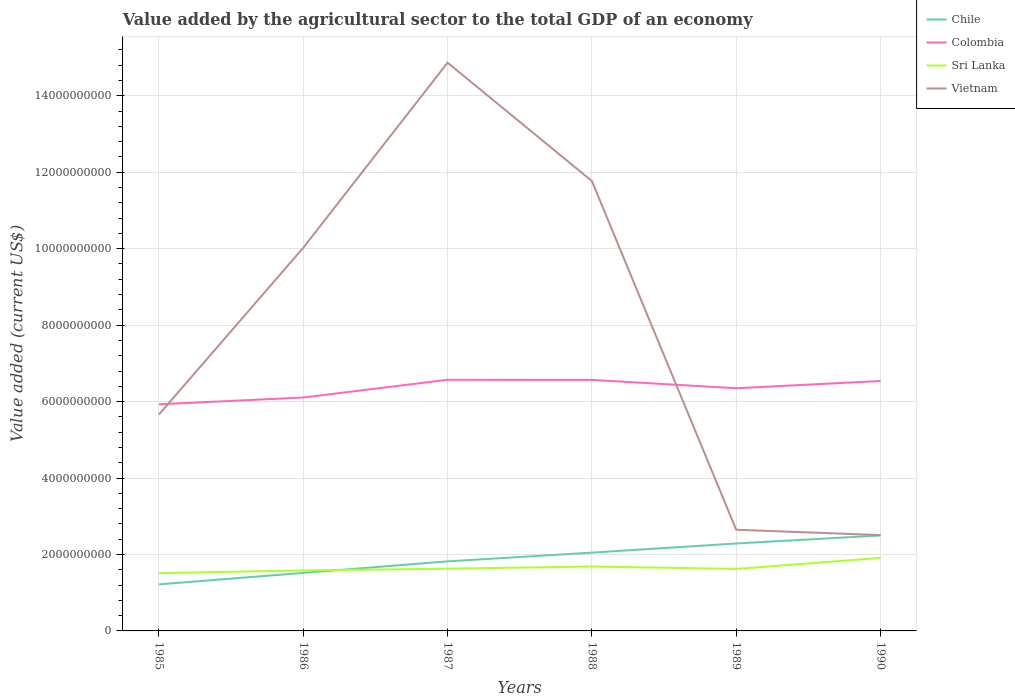How many different coloured lines are there?
Make the answer very short. 4. Does the line corresponding to Chile intersect with the line corresponding to Colombia?
Your response must be concise. No. Is the number of lines equal to the number of legend labels?
Ensure brevity in your answer.  Yes. Across all years, what is the maximum value added by the agricultural sector to the total GDP in Sri Lanka?
Provide a short and direct response. 1.51e+09. In which year was the value added by the agricultural sector to the total GDP in Vietnam maximum?
Provide a succinct answer. 1990. What is the total value added by the agricultural sector to the total GDP in Vietnam in the graph?
Keep it short and to the point. 3.16e+09. What is the difference between the highest and the second highest value added by the agricultural sector to the total GDP in Vietnam?
Your answer should be compact. 1.24e+1. What is the difference between the highest and the lowest value added by the agricultural sector to the total GDP in Sri Lanka?
Give a very brief answer. 2. Is the value added by the agricultural sector to the total GDP in Vietnam strictly greater than the value added by the agricultural sector to the total GDP in Colombia over the years?
Provide a short and direct response. No. How many lines are there?
Provide a short and direct response. 4. Where does the legend appear in the graph?
Ensure brevity in your answer.  Top right. What is the title of the graph?
Make the answer very short. Value added by the agricultural sector to the total GDP of an economy. Does "Guatemala" appear as one of the legend labels in the graph?
Make the answer very short. No. What is the label or title of the Y-axis?
Keep it short and to the point. Value added (current US$). What is the Value added (current US$) of Chile in 1985?
Make the answer very short. 1.22e+09. What is the Value added (current US$) in Colombia in 1985?
Your answer should be compact. 5.93e+09. What is the Value added (current US$) of Sri Lanka in 1985?
Your response must be concise. 1.51e+09. What is the Value added (current US$) in Vietnam in 1985?
Your answer should be compact. 5.66e+09. What is the Value added (current US$) in Chile in 1986?
Keep it short and to the point. 1.52e+09. What is the Value added (current US$) in Colombia in 1986?
Your answer should be compact. 6.11e+09. What is the Value added (current US$) of Sri Lanka in 1986?
Make the answer very short. 1.58e+09. What is the Value added (current US$) in Vietnam in 1986?
Keep it short and to the point. 1.00e+1. What is the Value added (current US$) in Chile in 1987?
Make the answer very short. 1.82e+09. What is the Value added (current US$) in Colombia in 1987?
Give a very brief answer. 6.57e+09. What is the Value added (current US$) in Sri Lanka in 1987?
Offer a very short reply. 1.63e+09. What is the Value added (current US$) in Vietnam in 1987?
Give a very brief answer. 1.49e+1. What is the Value added (current US$) in Chile in 1988?
Ensure brevity in your answer.  2.05e+09. What is the Value added (current US$) of Colombia in 1988?
Your response must be concise. 6.57e+09. What is the Value added (current US$) of Sri Lanka in 1988?
Your response must be concise. 1.69e+09. What is the Value added (current US$) in Vietnam in 1988?
Ensure brevity in your answer.  1.18e+1. What is the Value added (current US$) of Chile in 1989?
Offer a very short reply. 2.29e+09. What is the Value added (current US$) of Colombia in 1989?
Make the answer very short. 6.35e+09. What is the Value added (current US$) of Sri Lanka in 1989?
Your answer should be very brief. 1.62e+09. What is the Value added (current US$) in Vietnam in 1989?
Your answer should be very brief. 2.65e+09. What is the Value added (current US$) of Chile in 1990?
Keep it short and to the point. 2.50e+09. What is the Value added (current US$) of Colombia in 1990?
Give a very brief answer. 6.54e+09. What is the Value added (current US$) of Sri Lanka in 1990?
Provide a short and direct response. 1.91e+09. What is the Value added (current US$) of Vietnam in 1990?
Provide a succinct answer. 2.51e+09. Across all years, what is the maximum Value added (current US$) of Chile?
Give a very brief answer. 2.50e+09. Across all years, what is the maximum Value added (current US$) of Colombia?
Make the answer very short. 6.57e+09. Across all years, what is the maximum Value added (current US$) of Sri Lanka?
Keep it short and to the point. 1.91e+09. Across all years, what is the maximum Value added (current US$) of Vietnam?
Offer a terse response. 1.49e+1. Across all years, what is the minimum Value added (current US$) of Chile?
Ensure brevity in your answer.  1.22e+09. Across all years, what is the minimum Value added (current US$) of Colombia?
Give a very brief answer. 5.93e+09. Across all years, what is the minimum Value added (current US$) of Sri Lanka?
Provide a succinct answer. 1.51e+09. Across all years, what is the minimum Value added (current US$) in Vietnam?
Offer a terse response. 2.51e+09. What is the total Value added (current US$) in Chile in the graph?
Your response must be concise. 1.14e+1. What is the total Value added (current US$) in Colombia in the graph?
Offer a terse response. 3.81e+1. What is the total Value added (current US$) in Sri Lanka in the graph?
Keep it short and to the point. 9.94e+09. What is the total Value added (current US$) in Vietnam in the graph?
Provide a succinct answer. 4.75e+1. What is the difference between the Value added (current US$) in Chile in 1985 and that in 1986?
Your answer should be very brief. -3.00e+08. What is the difference between the Value added (current US$) in Colombia in 1985 and that in 1986?
Provide a short and direct response. -1.78e+08. What is the difference between the Value added (current US$) in Sri Lanka in 1985 and that in 1986?
Provide a short and direct response. -7.09e+07. What is the difference between the Value added (current US$) in Vietnam in 1985 and that in 1986?
Give a very brief answer. -4.36e+09. What is the difference between the Value added (current US$) in Chile in 1985 and that in 1987?
Give a very brief answer. -6.01e+08. What is the difference between the Value added (current US$) in Colombia in 1985 and that in 1987?
Offer a terse response. -6.42e+08. What is the difference between the Value added (current US$) in Sri Lanka in 1985 and that in 1987?
Ensure brevity in your answer.  -1.16e+08. What is the difference between the Value added (current US$) of Vietnam in 1985 and that in 1987?
Your answer should be very brief. -9.21e+09. What is the difference between the Value added (current US$) of Chile in 1985 and that in 1988?
Keep it short and to the point. -8.30e+08. What is the difference between the Value added (current US$) in Colombia in 1985 and that in 1988?
Keep it short and to the point. -6.39e+08. What is the difference between the Value added (current US$) of Sri Lanka in 1985 and that in 1988?
Offer a very short reply. -1.73e+08. What is the difference between the Value added (current US$) in Vietnam in 1985 and that in 1988?
Offer a terse response. -6.11e+09. What is the difference between the Value added (current US$) in Chile in 1985 and that in 1989?
Provide a short and direct response. -1.07e+09. What is the difference between the Value added (current US$) of Colombia in 1985 and that in 1989?
Offer a terse response. -4.20e+08. What is the difference between the Value added (current US$) of Sri Lanka in 1985 and that in 1989?
Provide a short and direct response. -1.10e+08. What is the difference between the Value added (current US$) in Vietnam in 1985 and that in 1989?
Provide a succinct answer. 3.01e+09. What is the difference between the Value added (current US$) of Chile in 1985 and that in 1990?
Your answer should be compact. -1.28e+09. What is the difference between the Value added (current US$) of Colombia in 1985 and that in 1990?
Your response must be concise. -6.10e+08. What is the difference between the Value added (current US$) in Sri Lanka in 1985 and that in 1990?
Provide a short and direct response. -3.97e+08. What is the difference between the Value added (current US$) of Vietnam in 1985 and that in 1990?
Offer a terse response. 3.16e+09. What is the difference between the Value added (current US$) in Chile in 1986 and that in 1987?
Give a very brief answer. -3.01e+08. What is the difference between the Value added (current US$) in Colombia in 1986 and that in 1987?
Offer a terse response. -4.64e+08. What is the difference between the Value added (current US$) of Sri Lanka in 1986 and that in 1987?
Make the answer very short. -4.48e+07. What is the difference between the Value added (current US$) in Vietnam in 1986 and that in 1987?
Keep it short and to the point. -4.84e+09. What is the difference between the Value added (current US$) of Chile in 1986 and that in 1988?
Your answer should be very brief. -5.30e+08. What is the difference between the Value added (current US$) in Colombia in 1986 and that in 1988?
Keep it short and to the point. -4.61e+08. What is the difference between the Value added (current US$) of Sri Lanka in 1986 and that in 1988?
Provide a short and direct response. -1.02e+08. What is the difference between the Value added (current US$) in Vietnam in 1986 and that in 1988?
Ensure brevity in your answer.  -1.75e+09. What is the difference between the Value added (current US$) in Chile in 1986 and that in 1989?
Ensure brevity in your answer.  -7.69e+08. What is the difference between the Value added (current US$) of Colombia in 1986 and that in 1989?
Keep it short and to the point. -2.42e+08. What is the difference between the Value added (current US$) of Sri Lanka in 1986 and that in 1989?
Your answer should be very brief. -3.87e+07. What is the difference between the Value added (current US$) in Vietnam in 1986 and that in 1989?
Ensure brevity in your answer.  7.38e+09. What is the difference between the Value added (current US$) of Chile in 1986 and that in 1990?
Ensure brevity in your answer.  -9.79e+08. What is the difference between the Value added (current US$) in Colombia in 1986 and that in 1990?
Offer a terse response. -4.32e+08. What is the difference between the Value added (current US$) of Sri Lanka in 1986 and that in 1990?
Give a very brief answer. -3.26e+08. What is the difference between the Value added (current US$) in Vietnam in 1986 and that in 1990?
Offer a terse response. 7.52e+09. What is the difference between the Value added (current US$) of Chile in 1987 and that in 1988?
Your answer should be compact. -2.29e+08. What is the difference between the Value added (current US$) in Colombia in 1987 and that in 1988?
Keep it short and to the point. 2.56e+06. What is the difference between the Value added (current US$) of Sri Lanka in 1987 and that in 1988?
Your answer should be very brief. -5.72e+07. What is the difference between the Value added (current US$) of Vietnam in 1987 and that in 1988?
Your response must be concise. 3.10e+09. What is the difference between the Value added (current US$) of Chile in 1987 and that in 1989?
Offer a very short reply. -4.68e+08. What is the difference between the Value added (current US$) of Colombia in 1987 and that in 1989?
Give a very brief answer. 2.21e+08. What is the difference between the Value added (current US$) of Sri Lanka in 1987 and that in 1989?
Keep it short and to the point. 6.13e+06. What is the difference between the Value added (current US$) in Vietnam in 1987 and that in 1989?
Provide a short and direct response. 1.22e+1. What is the difference between the Value added (current US$) of Chile in 1987 and that in 1990?
Offer a very short reply. -6.78e+08. What is the difference between the Value added (current US$) of Colombia in 1987 and that in 1990?
Offer a terse response. 3.17e+07. What is the difference between the Value added (current US$) in Sri Lanka in 1987 and that in 1990?
Make the answer very short. -2.82e+08. What is the difference between the Value added (current US$) in Vietnam in 1987 and that in 1990?
Provide a succinct answer. 1.24e+1. What is the difference between the Value added (current US$) of Chile in 1988 and that in 1989?
Keep it short and to the point. -2.39e+08. What is the difference between the Value added (current US$) in Colombia in 1988 and that in 1989?
Make the answer very short. 2.19e+08. What is the difference between the Value added (current US$) of Sri Lanka in 1988 and that in 1989?
Offer a very short reply. 6.33e+07. What is the difference between the Value added (current US$) of Vietnam in 1988 and that in 1989?
Your response must be concise. 9.12e+09. What is the difference between the Value added (current US$) of Chile in 1988 and that in 1990?
Offer a very short reply. -4.49e+08. What is the difference between the Value added (current US$) in Colombia in 1988 and that in 1990?
Your answer should be very brief. 2.92e+07. What is the difference between the Value added (current US$) of Sri Lanka in 1988 and that in 1990?
Offer a terse response. -2.24e+08. What is the difference between the Value added (current US$) in Vietnam in 1988 and that in 1990?
Your answer should be compact. 9.26e+09. What is the difference between the Value added (current US$) of Chile in 1989 and that in 1990?
Ensure brevity in your answer.  -2.10e+08. What is the difference between the Value added (current US$) in Colombia in 1989 and that in 1990?
Make the answer very short. -1.90e+08. What is the difference between the Value added (current US$) in Sri Lanka in 1989 and that in 1990?
Offer a terse response. -2.88e+08. What is the difference between the Value added (current US$) of Vietnam in 1989 and that in 1990?
Keep it short and to the point. 1.40e+08. What is the difference between the Value added (current US$) of Chile in 1985 and the Value added (current US$) of Colombia in 1986?
Give a very brief answer. -4.89e+09. What is the difference between the Value added (current US$) of Chile in 1985 and the Value added (current US$) of Sri Lanka in 1986?
Make the answer very short. -3.65e+08. What is the difference between the Value added (current US$) of Chile in 1985 and the Value added (current US$) of Vietnam in 1986?
Your answer should be compact. -8.81e+09. What is the difference between the Value added (current US$) of Colombia in 1985 and the Value added (current US$) of Sri Lanka in 1986?
Your response must be concise. 4.35e+09. What is the difference between the Value added (current US$) in Colombia in 1985 and the Value added (current US$) in Vietnam in 1986?
Provide a succinct answer. -4.10e+09. What is the difference between the Value added (current US$) of Sri Lanka in 1985 and the Value added (current US$) of Vietnam in 1986?
Provide a short and direct response. -8.51e+09. What is the difference between the Value added (current US$) in Chile in 1985 and the Value added (current US$) in Colombia in 1987?
Offer a terse response. -5.35e+09. What is the difference between the Value added (current US$) in Chile in 1985 and the Value added (current US$) in Sri Lanka in 1987?
Your response must be concise. -4.10e+08. What is the difference between the Value added (current US$) in Chile in 1985 and the Value added (current US$) in Vietnam in 1987?
Provide a short and direct response. -1.36e+1. What is the difference between the Value added (current US$) in Colombia in 1985 and the Value added (current US$) in Sri Lanka in 1987?
Make the answer very short. 4.30e+09. What is the difference between the Value added (current US$) of Colombia in 1985 and the Value added (current US$) of Vietnam in 1987?
Your answer should be very brief. -8.94e+09. What is the difference between the Value added (current US$) in Sri Lanka in 1985 and the Value added (current US$) in Vietnam in 1987?
Your response must be concise. -1.34e+1. What is the difference between the Value added (current US$) in Chile in 1985 and the Value added (current US$) in Colombia in 1988?
Offer a very short reply. -5.35e+09. What is the difference between the Value added (current US$) of Chile in 1985 and the Value added (current US$) of Sri Lanka in 1988?
Make the answer very short. -4.67e+08. What is the difference between the Value added (current US$) of Chile in 1985 and the Value added (current US$) of Vietnam in 1988?
Offer a very short reply. -1.06e+1. What is the difference between the Value added (current US$) in Colombia in 1985 and the Value added (current US$) in Sri Lanka in 1988?
Provide a short and direct response. 4.24e+09. What is the difference between the Value added (current US$) in Colombia in 1985 and the Value added (current US$) in Vietnam in 1988?
Provide a succinct answer. -5.84e+09. What is the difference between the Value added (current US$) of Sri Lanka in 1985 and the Value added (current US$) of Vietnam in 1988?
Your answer should be compact. -1.03e+1. What is the difference between the Value added (current US$) in Chile in 1985 and the Value added (current US$) in Colombia in 1989?
Ensure brevity in your answer.  -5.13e+09. What is the difference between the Value added (current US$) of Chile in 1985 and the Value added (current US$) of Sri Lanka in 1989?
Provide a succinct answer. -4.03e+08. What is the difference between the Value added (current US$) of Chile in 1985 and the Value added (current US$) of Vietnam in 1989?
Your answer should be very brief. -1.43e+09. What is the difference between the Value added (current US$) of Colombia in 1985 and the Value added (current US$) of Sri Lanka in 1989?
Offer a terse response. 4.31e+09. What is the difference between the Value added (current US$) in Colombia in 1985 and the Value added (current US$) in Vietnam in 1989?
Provide a short and direct response. 3.28e+09. What is the difference between the Value added (current US$) of Sri Lanka in 1985 and the Value added (current US$) of Vietnam in 1989?
Offer a terse response. -1.14e+09. What is the difference between the Value added (current US$) in Chile in 1985 and the Value added (current US$) in Colombia in 1990?
Your response must be concise. -5.32e+09. What is the difference between the Value added (current US$) in Chile in 1985 and the Value added (current US$) in Sri Lanka in 1990?
Your answer should be compact. -6.91e+08. What is the difference between the Value added (current US$) in Chile in 1985 and the Value added (current US$) in Vietnam in 1990?
Make the answer very short. -1.29e+09. What is the difference between the Value added (current US$) in Colombia in 1985 and the Value added (current US$) in Sri Lanka in 1990?
Your answer should be very brief. 4.02e+09. What is the difference between the Value added (current US$) of Colombia in 1985 and the Value added (current US$) of Vietnam in 1990?
Give a very brief answer. 3.42e+09. What is the difference between the Value added (current US$) of Sri Lanka in 1985 and the Value added (current US$) of Vietnam in 1990?
Provide a succinct answer. -9.95e+08. What is the difference between the Value added (current US$) of Chile in 1986 and the Value added (current US$) of Colombia in 1987?
Give a very brief answer. -5.05e+09. What is the difference between the Value added (current US$) of Chile in 1986 and the Value added (current US$) of Sri Lanka in 1987?
Make the answer very short. -1.09e+08. What is the difference between the Value added (current US$) of Chile in 1986 and the Value added (current US$) of Vietnam in 1987?
Provide a succinct answer. -1.33e+1. What is the difference between the Value added (current US$) of Colombia in 1986 and the Value added (current US$) of Sri Lanka in 1987?
Provide a short and direct response. 4.48e+09. What is the difference between the Value added (current US$) in Colombia in 1986 and the Value added (current US$) in Vietnam in 1987?
Make the answer very short. -8.76e+09. What is the difference between the Value added (current US$) in Sri Lanka in 1986 and the Value added (current US$) in Vietnam in 1987?
Ensure brevity in your answer.  -1.33e+1. What is the difference between the Value added (current US$) in Chile in 1986 and the Value added (current US$) in Colombia in 1988?
Your response must be concise. -5.05e+09. What is the difference between the Value added (current US$) of Chile in 1986 and the Value added (current US$) of Sri Lanka in 1988?
Your response must be concise. -1.66e+08. What is the difference between the Value added (current US$) of Chile in 1986 and the Value added (current US$) of Vietnam in 1988?
Offer a very short reply. -1.03e+1. What is the difference between the Value added (current US$) in Colombia in 1986 and the Value added (current US$) in Sri Lanka in 1988?
Offer a very short reply. 4.42e+09. What is the difference between the Value added (current US$) in Colombia in 1986 and the Value added (current US$) in Vietnam in 1988?
Provide a succinct answer. -5.66e+09. What is the difference between the Value added (current US$) in Sri Lanka in 1986 and the Value added (current US$) in Vietnam in 1988?
Give a very brief answer. -1.02e+1. What is the difference between the Value added (current US$) in Chile in 1986 and the Value added (current US$) in Colombia in 1989?
Give a very brief answer. -4.83e+09. What is the difference between the Value added (current US$) of Chile in 1986 and the Value added (current US$) of Sri Lanka in 1989?
Your response must be concise. -1.03e+08. What is the difference between the Value added (current US$) in Chile in 1986 and the Value added (current US$) in Vietnam in 1989?
Offer a very short reply. -1.13e+09. What is the difference between the Value added (current US$) in Colombia in 1986 and the Value added (current US$) in Sri Lanka in 1989?
Make the answer very short. 4.49e+09. What is the difference between the Value added (current US$) of Colombia in 1986 and the Value added (current US$) of Vietnam in 1989?
Provide a short and direct response. 3.46e+09. What is the difference between the Value added (current US$) of Sri Lanka in 1986 and the Value added (current US$) of Vietnam in 1989?
Your answer should be compact. -1.06e+09. What is the difference between the Value added (current US$) in Chile in 1986 and the Value added (current US$) in Colombia in 1990?
Your answer should be compact. -5.02e+09. What is the difference between the Value added (current US$) of Chile in 1986 and the Value added (current US$) of Sri Lanka in 1990?
Your answer should be very brief. -3.91e+08. What is the difference between the Value added (current US$) in Chile in 1986 and the Value added (current US$) in Vietnam in 1990?
Keep it short and to the point. -9.88e+08. What is the difference between the Value added (current US$) in Colombia in 1986 and the Value added (current US$) in Sri Lanka in 1990?
Provide a short and direct response. 4.20e+09. What is the difference between the Value added (current US$) in Colombia in 1986 and the Value added (current US$) in Vietnam in 1990?
Ensure brevity in your answer.  3.60e+09. What is the difference between the Value added (current US$) of Sri Lanka in 1986 and the Value added (current US$) of Vietnam in 1990?
Provide a succinct answer. -9.24e+08. What is the difference between the Value added (current US$) in Chile in 1987 and the Value added (current US$) in Colombia in 1988?
Keep it short and to the point. -4.75e+09. What is the difference between the Value added (current US$) in Chile in 1987 and the Value added (current US$) in Sri Lanka in 1988?
Offer a very short reply. 1.35e+08. What is the difference between the Value added (current US$) of Chile in 1987 and the Value added (current US$) of Vietnam in 1988?
Offer a terse response. -9.95e+09. What is the difference between the Value added (current US$) in Colombia in 1987 and the Value added (current US$) in Sri Lanka in 1988?
Make the answer very short. 4.89e+09. What is the difference between the Value added (current US$) of Colombia in 1987 and the Value added (current US$) of Vietnam in 1988?
Make the answer very short. -5.20e+09. What is the difference between the Value added (current US$) of Sri Lanka in 1987 and the Value added (current US$) of Vietnam in 1988?
Make the answer very short. -1.01e+1. What is the difference between the Value added (current US$) in Chile in 1987 and the Value added (current US$) in Colombia in 1989?
Make the answer very short. -4.53e+09. What is the difference between the Value added (current US$) in Chile in 1987 and the Value added (current US$) in Sri Lanka in 1989?
Keep it short and to the point. 1.98e+08. What is the difference between the Value added (current US$) of Chile in 1987 and the Value added (current US$) of Vietnam in 1989?
Offer a very short reply. -8.28e+08. What is the difference between the Value added (current US$) of Colombia in 1987 and the Value added (current US$) of Sri Lanka in 1989?
Make the answer very short. 4.95e+09. What is the difference between the Value added (current US$) in Colombia in 1987 and the Value added (current US$) in Vietnam in 1989?
Your answer should be compact. 3.92e+09. What is the difference between the Value added (current US$) in Sri Lanka in 1987 and the Value added (current US$) in Vietnam in 1989?
Your answer should be compact. -1.02e+09. What is the difference between the Value added (current US$) of Chile in 1987 and the Value added (current US$) of Colombia in 1990?
Ensure brevity in your answer.  -4.72e+09. What is the difference between the Value added (current US$) in Chile in 1987 and the Value added (current US$) in Sri Lanka in 1990?
Ensure brevity in your answer.  -8.96e+07. What is the difference between the Value added (current US$) of Chile in 1987 and the Value added (current US$) of Vietnam in 1990?
Keep it short and to the point. -6.87e+08. What is the difference between the Value added (current US$) of Colombia in 1987 and the Value added (current US$) of Sri Lanka in 1990?
Your response must be concise. 4.66e+09. What is the difference between the Value added (current US$) in Colombia in 1987 and the Value added (current US$) in Vietnam in 1990?
Your answer should be compact. 4.06e+09. What is the difference between the Value added (current US$) of Sri Lanka in 1987 and the Value added (current US$) of Vietnam in 1990?
Ensure brevity in your answer.  -8.79e+08. What is the difference between the Value added (current US$) in Chile in 1988 and the Value added (current US$) in Colombia in 1989?
Provide a short and direct response. -4.30e+09. What is the difference between the Value added (current US$) in Chile in 1988 and the Value added (current US$) in Sri Lanka in 1989?
Your response must be concise. 4.27e+08. What is the difference between the Value added (current US$) in Chile in 1988 and the Value added (current US$) in Vietnam in 1989?
Provide a short and direct response. -5.99e+08. What is the difference between the Value added (current US$) in Colombia in 1988 and the Value added (current US$) in Sri Lanka in 1989?
Make the answer very short. 4.95e+09. What is the difference between the Value added (current US$) in Colombia in 1988 and the Value added (current US$) in Vietnam in 1989?
Your answer should be very brief. 3.92e+09. What is the difference between the Value added (current US$) in Sri Lanka in 1988 and the Value added (current US$) in Vietnam in 1989?
Keep it short and to the point. -9.62e+08. What is the difference between the Value added (current US$) of Chile in 1988 and the Value added (current US$) of Colombia in 1990?
Provide a short and direct response. -4.49e+09. What is the difference between the Value added (current US$) in Chile in 1988 and the Value added (current US$) in Sri Lanka in 1990?
Your answer should be compact. 1.39e+08. What is the difference between the Value added (current US$) of Chile in 1988 and the Value added (current US$) of Vietnam in 1990?
Provide a short and direct response. -4.58e+08. What is the difference between the Value added (current US$) of Colombia in 1988 and the Value added (current US$) of Sri Lanka in 1990?
Offer a very short reply. 4.66e+09. What is the difference between the Value added (current US$) of Colombia in 1988 and the Value added (current US$) of Vietnam in 1990?
Ensure brevity in your answer.  4.06e+09. What is the difference between the Value added (current US$) of Sri Lanka in 1988 and the Value added (current US$) of Vietnam in 1990?
Ensure brevity in your answer.  -8.22e+08. What is the difference between the Value added (current US$) in Chile in 1989 and the Value added (current US$) in Colombia in 1990?
Your response must be concise. -4.25e+09. What is the difference between the Value added (current US$) of Chile in 1989 and the Value added (current US$) of Sri Lanka in 1990?
Make the answer very short. 3.78e+08. What is the difference between the Value added (current US$) of Chile in 1989 and the Value added (current US$) of Vietnam in 1990?
Your answer should be very brief. -2.19e+08. What is the difference between the Value added (current US$) in Colombia in 1989 and the Value added (current US$) in Sri Lanka in 1990?
Your answer should be compact. 4.44e+09. What is the difference between the Value added (current US$) of Colombia in 1989 and the Value added (current US$) of Vietnam in 1990?
Provide a short and direct response. 3.84e+09. What is the difference between the Value added (current US$) of Sri Lanka in 1989 and the Value added (current US$) of Vietnam in 1990?
Provide a short and direct response. -8.85e+08. What is the average Value added (current US$) in Chile per year?
Your answer should be compact. 1.90e+09. What is the average Value added (current US$) in Colombia per year?
Offer a terse response. 6.34e+09. What is the average Value added (current US$) of Sri Lanka per year?
Your answer should be compact. 1.66e+09. What is the average Value added (current US$) in Vietnam per year?
Offer a very short reply. 7.91e+09. In the year 1985, what is the difference between the Value added (current US$) of Chile and Value added (current US$) of Colombia?
Provide a short and direct response. -4.71e+09. In the year 1985, what is the difference between the Value added (current US$) in Chile and Value added (current US$) in Sri Lanka?
Keep it short and to the point. -2.94e+08. In the year 1985, what is the difference between the Value added (current US$) in Chile and Value added (current US$) in Vietnam?
Ensure brevity in your answer.  -4.44e+09. In the year 1985, what is the difference between the Value added (current US$) in Colombia and Value added (current US$) in Sri Lanka?
Make the answer very short. 4.42e+09. In the year 1985, what is the difference between the Value added (current US$) in Colombia and Value added (current US$) in Vietnam?
Ensure brevity in your answer.  2.67e+08. In the year 1985, what is the difference between the Value added (current US$) of Sri Lanka and Value added (current US$) of Vietnam?
Your response must be concise. -4.15e+09. In the year 1986, what is the difference between the Value added (current US$) of Chile and Value added (current US$) of Colombia?
Ensure brevity in your answer.  -4.59e+09. In the year 1986, what is the difference between the Value added (current US$) in Chile and Value added (current US$) in Sri Lanka?
Make the answer very short. -6.42e+07. In the year 1986, what is the difference between the Value added (current US$) in Chile and Value added (current US$) in Vietnam?
Provide a succinct answer. -8.51e+09. In the year 1986, what is the difference between the Value added (current US$) of Colombia and Value added (current US$) of Sri Lanka?
Keep it short and to the point. 4.52e+09. In the year 1986, what is the difference between the Value added (current US$) in Colombia and Value added (current US$) in Vietnam?
Your response must be concise. -3.92e+09. In the year 1986, what is the difference between the Value added (current US$) in Sri Lanka and Value added (current US$) in Vietnam?
Your response must be concise. -8.44e+09. In the year 1987, what is the difference between the Value added (current US$) of Chile and Value added (current US$) of Colombia?
Offer a very short reply. -4.75e+09. In the year 1987, what is the difference between the Value added (current US$) in Chile and Value added (current US$) in Sri Lanka?
Provide a succinct answer. 1.92e+08. In the year 1987, what is the difference between the Value added (current US$) in Chile and Value added (current US$) in Vietnam?
Provide a short and direct response. -1.30e+1. In the year 1987, what is the difference between the Value added (current US$) in Colombia and Value added (current US$) in Sri Lanka?
Your answer should be compact. 4.94e+09. In the year 1987, what is the difference between the Value added (current US$) of Colombia and Value added (current US$) of Vietnam?
Your answer should be very brief. -8.30e+09. In the year 1987, what is the difference between the Value added (current US$) in Sri Lanka and Value added (current US$) in Vietnam?
Your response must be concise. -1.32e+1. In the year 1988, what is the difference between the Value added (current US$) of Chile and Value added (current US$) of Colombia?
Your answer should be very brief. -4.52e+09. In the year 1988, what is the difference between the Value added (current US$) of Chile and Value added (current US$) of Sri Lanka?
Offer a terse response. 3.64e+08. In the year 1988, what is the difference between the Value added (current US$) in Chile and Value added (current US$) in Vietnam?
Your answer should be very brief. -9.72e+09. In the year 1988, what is the difference between the Value added (current US$) in Colombia and Value added (current US$) in Sri Lanka?
Provide a short and direct response. 4.88e+09. In the year 1988, what is the difference between the Value added (current US$) of Colombia and Value added (current US$) of Vietnam?
Ensure brevity in your answer.  -5.20e+09. In the year 1988, what is the difference between the Value added (current US$) of Sri Lanka and Value added (current US$) of Vietnam?
Your answer should be compact. -1.01e+1. In the year 1989, what is the difference between the Value added (current US$) of Chile and Value added (current US$) of Colombia?
Your answer should be compact. -4.06e+09. In the year 1989, what is the difference between the Value added (current US$) of Chile and Value added (current US$) of Sri Lanka?
Your answer should be very brief. 6.66e+08. In the year 1989, what is the difference between the Value added (current US$) in Chile and Value added (current US$) in Vietnam?
Your response must be concise. -3.60e+08. In the year 1989, what is the difference between the Value added (current US$) in Colombia and Value added (current US$) in Sri Lanka?
Make the answer very short. 4.73e+09. In the year 1989, what is the difference between the Value added (current US$) in Colombia and Value added (current US$) in Vietnam?
Your response must be concise. 3.70e+09. In the year 1989, what is the difference between the Value added (current US$) of Sri Lanka and Value added (current US$) of Vietnam?
Your answer should be very brief. -1.03e+09. In the year 1990, what is the difference between the Value added (current US$) in Chile and Value added (current US$) in Colombia?
Ensure brevity in your answer.  -4.04e+09. In the year 1990, what is the difference between the Value added (current US$) in Chile and Value added (current US$) in Sri Lanka?
Give a very brief answer. 5.88e+08. In the year 1990, what is the difference between the Value added (current US$) of Chile and Value added (current US$) of Vietnam?
Your answer should be compact. -9.38e+06. In the year 1990, what is the difference between the Value added (current US$) of Colombia and Value added (current US$) of Sri Lanka?
Keep it short and to the point. 4.63e+09. In the year 1990, what is the difference between the Value added (current US$) of Colombia and Value added (current US$) of Vietnam?
Your response must be concise. 4.03e+09. In the year 1990, what is the difference between the Value added (current US$) of Sri Lanka and Value added (current US$) of Vietnam?
Ensure brevity in your answer.  -5.98e+08. What is the ratio of the Value added (current US$) of Chile in 1985 to that in 1986?
Ensure brevity in your answer.  0.8. What is the ratio of the Value added (current US$) in Colombia in 1985 to that in 1986?
Provide a short and direct response. 0.97. What is the ratio of the Value added (current US$) in Sri Lanka in 1985 to that in 1986?
Give a very brief answer. 0.96. What is the ratio of the Value added (current US$) in Vietnam in 1985 to that in 1986?
Provide a short and direct response. 0.56. What is the ratio of the Value added (current US$) of Chile in 1985 to that in 1987?
Make the answer very short. 0.67. What is the ratio of the Value added (current US$) in Colombia in 1985 to that in 1987?
Offer a very short reply. 0.9. What is the ratio of the Value added (current US$) in Sri Lanka in 1985 to that in 1987?
Keep it short and to the point. 0.93. What is the ratio of the Value added (current US$) in Vietnam in 1985 to that in 1987?
Offer a terse response. 0.38. What is the ratio of the Value added (current US$) in Chile in 1985 to that in 1988?
Offer a terse response. 0.59. What is the ratio of the Value added (current US$) in Colombia in 1985 to that in 1988?
Ensure brevity in your answer.  0.9. What is the ratio of the Value added (current US$) in Sri Lanka in 1985 to that in 1988?
Offer a very short reply. 0.9. What is the ratio of the Value added (current US$) of Vietnam in 1985 to that in 1988?
Your answer should be very brief. 0.48. What is the ratio of the Value added (current US$) of Chile in 1985 to that in 1989?
Provide a succinct answer. 0.53. What is the ratio of the Value added (current US$) of Colombia in 1985 to that in 1989?
Provide a short and direct response. 0.93. What is the ratio of the Value added (current US$) of Sri Lanka in 1985 to that in 1989?
Provide a succinct answer. 0.93. What is the ratio of the Value added (current US$) of Vietnam in 1985 to that in 1989?
Keep it short and to the point. 2.14. What is the ratio of the Value added (current US$) in Chile in 1985 to that in 1990?
Make the answer very short. 0.49. What is the ratio of the Value added (current US$) of Colombia in 1985 to that in 1990?
Provide a short and direct response. 0.91. What is the ratio of the Value added (current US$) of Sri Lanka in 1985 to that in 1990?
Your answer should be compact. 0.79. What is the ratio of the Value added (current US$) in Vietnam in 1985 to that in 1990?
Keep it short and to the point. 2.26. What is the ratio of the Value added (current US$) of Chile in 1986 to that in 1987?
Your answer should be very brief. 0.83. What is the ratio of the Value added (current US$) of Colombia in 1986 to that in 1987?
Ensure brevity in your answer.  0.93. What is the ratio of the Value added (current US$) of Sri Lanka in 1986 to that in 1987?
Make the answer very short. 0.97. What is the ratio of the Value added (current US$) in Vietnam in 1986 to that in 1987?
Your answer should be very brief. 0.67. What is the ratio of the Value added (current US$) of Chile in 1986 to that in 1988?
Offer a very short reply. 0.74. What is the ratio of the Value added (current US$) of Colombia in 1986 to that in 1988?
Give a very brief answer. 0.93. What is the ratio of the Value added (current US$) of Sri Lanka in 1986 to that in 1988?
Offer a very short reply. 0.94. What is the ratio of the Value added (current US$) of Vietnam in 1986 to that in 1988?
Provide a short and direct response. 0.85. What is the ratio of the Value added (current US$) in Chile in 1986 to that in 1989?
Provide a succinct answer. 0.66. What is the ratio of the Value added (current US$) of Colombia in 1986 to that in 1989?
Give a very brief answer. 0.96. What is the ratio of the Value added (current US$) of Sri Lanka in 1986 to that in 1989?
Your response must be concise. 0.98. What is the ratio of the Value added (current US$) of Vietnam in 1986 to that in 1989?
Your answer should be very brief. 3.79. What is the ratio of the Value added (current US$) of Chile in 1986 to that in 1990?
Ensure brevity in your answer.  0.61. What is the ratio of the Value added (current US$) of Colombia in 1986 to that in 1990?
Offer a terse response. 0.93. What is the ratio of the Value added (current US$) of Sri Lanka in 1986 to that in 1990?
Make the answer very short. 0.83. What is the ratio of the Value added (current US$) of Vietnam in 1986 to that in 1990?
Provide a succinct answer. 4. What is the ratio of the Value added (current US$) in Chile in 1987 to that in 1988?
Your answer should be compact. 0.89. What is the ratio of the Value added (current US$) of Sri Lanka in 1987 to that in 1988?
Your answer should be very brief. 0.97. What is the ratio of the Value added (current US$) of Vietnam in 1987 to that in 1988?
Make the answer very short. 1.26. What is the ratio of the Value added (current US$) in Chile in 1987 to that in 1989?
Your response must be concise. 0.8. What is the ratio of the Value added (current US$) in Colombia in 1987 to that in 1989?
Your answer should be compact. 1.03. What is the ratio of the Value added (current US$) of Vietnam in 1987 to that in 1989?
Ensure brevity in your answer.  5.62. What is the ratio of the Value added (current US$) in Chile in 1987 to that in 1990?
Offer a terse response. 0.73. What is the ratio of the Value added (current US$) of Colombia in 1987 to that in 1990?
Give a very brief answer. 1. What is the ratio of the Value added (current US$) in Sri Lanka in 1987 to that in 1990?
Offer a terse response. 0.85. What is the ratio of the Value added (current US$) of Vietnam in 1987 to that in 1990?
Keep it short and to the point. 5.93. What is the ratio of the Value added (current US$) of Chile in 1988 to that in 1989?
Your answer should be compact. 0.9. What is the ratio of the Value added (current US$) in Colombia in 1988 to that in 1989?
Provide a succinct answer. 1.03. What is the ratio of the Value added (current US$) in Sri Lanka in 1988 to that in 1989?
Keep it short and to the point. 1.04. What is the ratio of the Value added (current US$) of Vietnam in 1988 to that in 1989?
Provide a succinct answer. 4.45. What is the ratio of the Value added (current US$) in Chile in 1988 to that in 1990?
Offer a very short reply. 0.82. What is the ratio of the Value added (current US$) of Colombia in 1988 to that in 1990?
Make the answer very short. 1. What is the ratio of the Value added (current US$) of Sri Lanka in 1988 to that in 1990?
Your response must be concise. 0.88. What is the ratio of the Value added (current US$) in Vietnam in 1988 to that in 1990?
Provide a short and direct response. 4.7. What is the ratio of the Value added (current US$) in Chile in 1989 to that in 1990?
Give a very brief answer. 0.92. What is the ratio of the Value added (current US$) of Colombia in 1989 to that in 1990?
Provide a succinct answer. 0.97. What is the ratio of the Value added (current US$) in Sri Lanka in 1989 to that in 1990?
Keep it short and to the point. 0.85. What is the ratio of the Value added (current US$) in Vietnam in 1989 to that in 1990?
Give a very brief answer. 1.06. What is the difference between the highest and the second highest Value added (current US$) of Chile?
Give a very brief answer. 2.10e+08. What is the difference between the highest and the second highest Value added (current US$) of Colombia?
Make the answer very short. 2.56e+06. What is the difference between the highest and the second highest Value added (current US$) of Sri Lanka?
Give a very brief answer. 2.24e+08. What is the difference between the highest and the second highest Value added (current US$) of Vietnam?
Make the answer very short. 3.10e+09. What is the difference between the highest and the lowest Value added (current US$) in Chile?
Your response must be concise. 1.28e+09. What is the difference between the highest and the lowest Value added (current US$) of Colombia?
Provide a short and direct response. 6.42e+08. What is the difference between the highest and the lowest Value added (current US$) in Sri Lanka?
Provide a succinct answer. 3.97e+08. What is the difference between the highest and the lowest Value added (current US$) of Vietnam?
Your answer should be compact. 1.24e+1. 